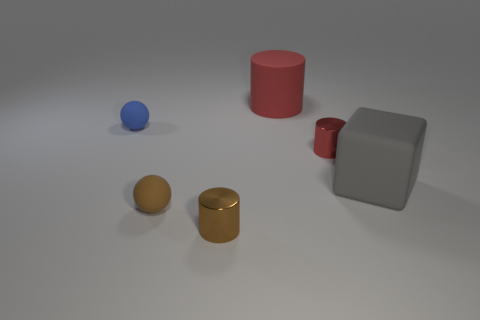Is there any other thing that has the same shape as the big gray thing?
Ensure brevity in your answer.  No. There is a rubber thing to the right of the tiny metal cylinder that is right of the large thing that is behind the tiny blue matte thing; what is its shape?
Your response must be concise. Cube. What number of big gray cubes are the same material as the blue thing?
Your response must be concise. 1. There is a tiny ball that is behind the small brown ball; how many tiny balls are in front of it?
Offer a very short reply. 1. How many small metallic objects are there?
Give a very brief answer. 2. Do the tiny red object and the brown object on the right side of the small brown rubber thing have the same material?
Keep it short and to the point. Yes. There is a rubber ball that is in front of the blue rubber ball; is it the same color as the large cylinder?
Keep it short and to the point. No. There is a cylinder that is both in front of the blue object and behind the tiny brown metallic object; what is its material?
Offer a very short reply. Metal. The blue rubber sphere is what size?
Provide a short and direct response. Small. There is a large cylinder; is it the same color as the small shiny cylinder that is behind the brown sphere?
Keep it short and to the point. Yes. 